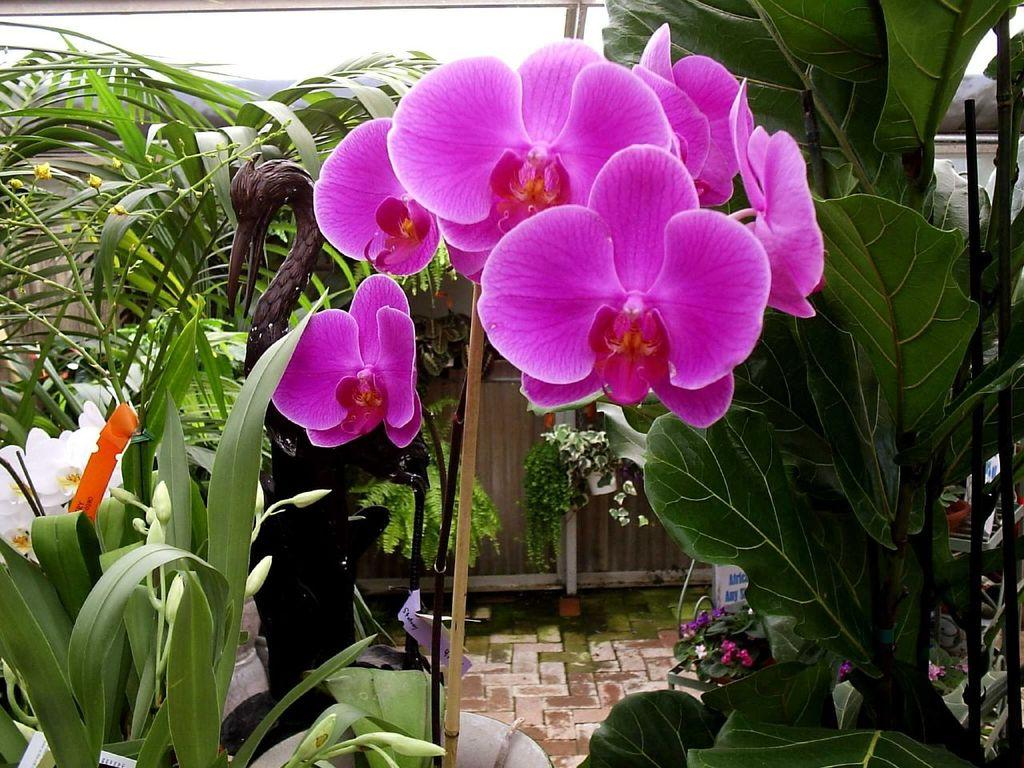What type of flora is present in the image? There are flowers in the image. What colors are the flowers? The flowers are in purple and white colors. What can be seen in the background of the image? There are trees and the sky visible in the background of the image. What is the color of the trees? The trees are green in color. What is the color of the sky in the image? The sky is white in color. What scientific experiment is being conducted with the flowers in the image? There is no indication of a scientific experiment being conducted in the image; it simply shows flowers, trees, and the sky. 